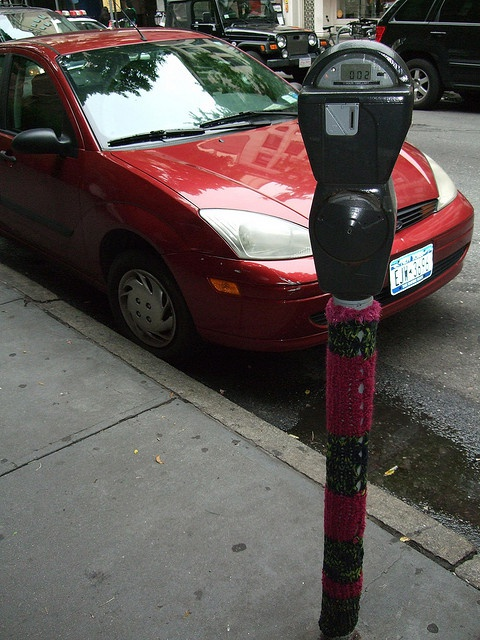Describe the objects in this image and their specific colors. I can see car in darkgray, black, white, salmon, and maroon tones, parking meter in darkgray, black, and gray tones, car in darkgray, black, gray, and brown tones, car in darkgray, black, gray, and darkgreen tones, and car in darkgray, gray, white, and black tones in this image. 